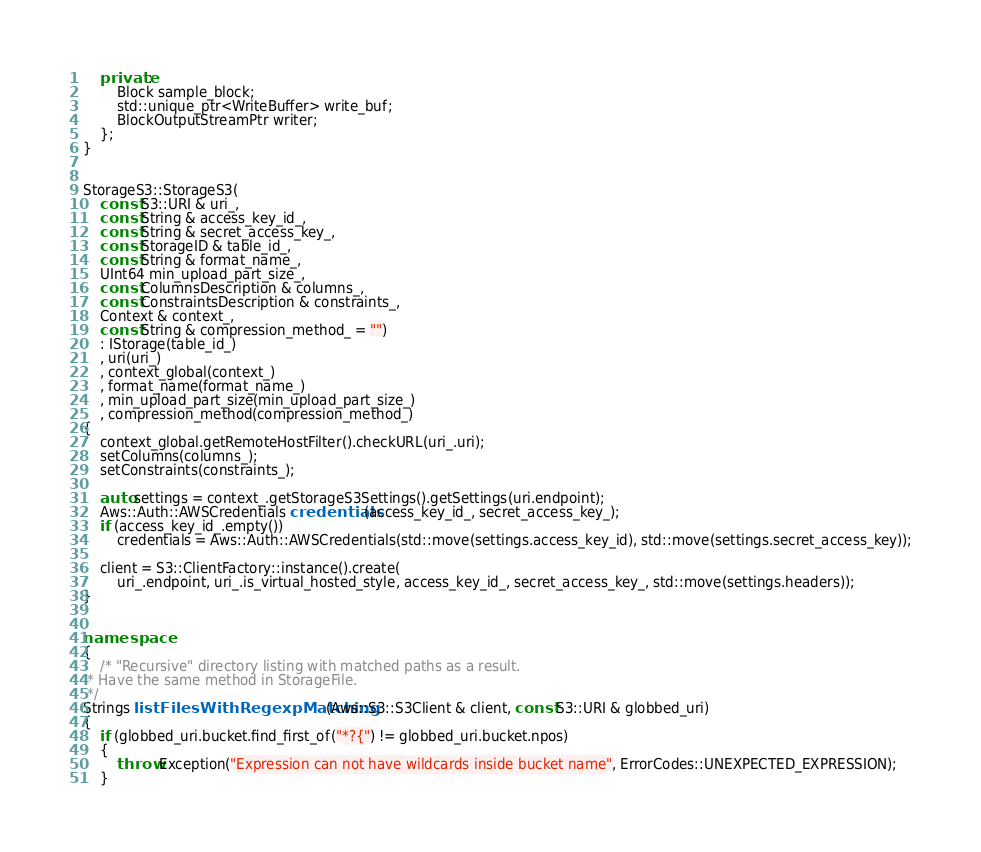Convert code to text. <code><loc_0><loc_0><loc_500><loc_500><_C++_>
    private:
        Block sample_block;
        std::unique_ptr<WriteBuffer> write_buf;
        BlockOutputStreamPtr writer;
    };
}


StorageS3::StorageS3(
    const S3::URI & uri_,
    const String & access_key_id_,
    const String & secret_access_key_,
    const StorageID & table_id_,
    const String & format_name_,
    UInt64 min_upload_part_size_,
    const ColumnsDescription & columns_,
    const ConstraintsDescription & constraints_,
    Context & context_,
    const String & compression_method_ = "")
    : IStorage(table_id_)
    , uri(uri_)
    , context_global(context_)
    , format_name(format_name_)
    , min_upload_part_size(min_upload_part_size_)
    , compression_method(compression_method_)
{
    context_global.getRemoteHostFilter().checkURL(uri_.uri);
    setColumns(columns_);
    setConstraints(constraints_);

    auto settings = context_.getStorageS3Settings().getSettings(uri.endpoint);
    Aws::Auth::AWSCredentials credentials(access_key_id_, secret_access_key_);
    if (access_key_id_.empty())
        credentials = Aws::Auth::AWSCredentials(std::move(settings.access_key_id), std::move(settings.secret_access_key));

    client = S3::ClientFactory::instance().create(
        uri_.endpoint, uri_.is_virtual_hosted_style, access_key_id_, secret_access_key_, std::move(settings.headers));
}


namespace
{
    /* "Recursive" directory listing with matched paths as a result.
 * Have the same method in StorageFile.
 */
Strings listFilesWithRegexpMatching(Aws::S3::S3Client & client, const S3::URI & globbed_uri)
{
    if (globbed_uri.bucket.find_first_of("*?{") != globbed_uri.bucket.npos)
    {
        throw Exception("Expression can not have wildcards inside bucket name", ErrorCodes::UNEXPECTED_EXPRESSION);
    }
</code> 